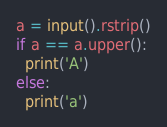<code> <loc_0><loc_0><loc_500><loc_500><_Python_>a = input().rstrip()
if a == a.upper():
  print('A')
else:
  print('a')
</code> 